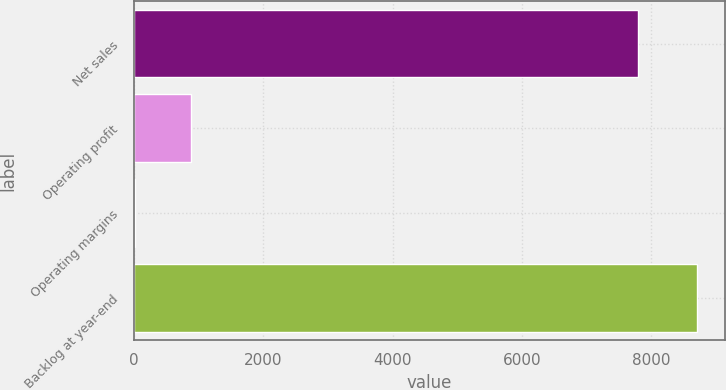<chart> <loc_0><loc_0><loc_500><loc_500><bar_chart><fcel>Net sales<fcel>Operating profit<fcel>Operating margins<fcel>Backlog at year-end<nl><fcel>7788<fcel>878.1<fcel>9<fcel>8700<nl></chart> 